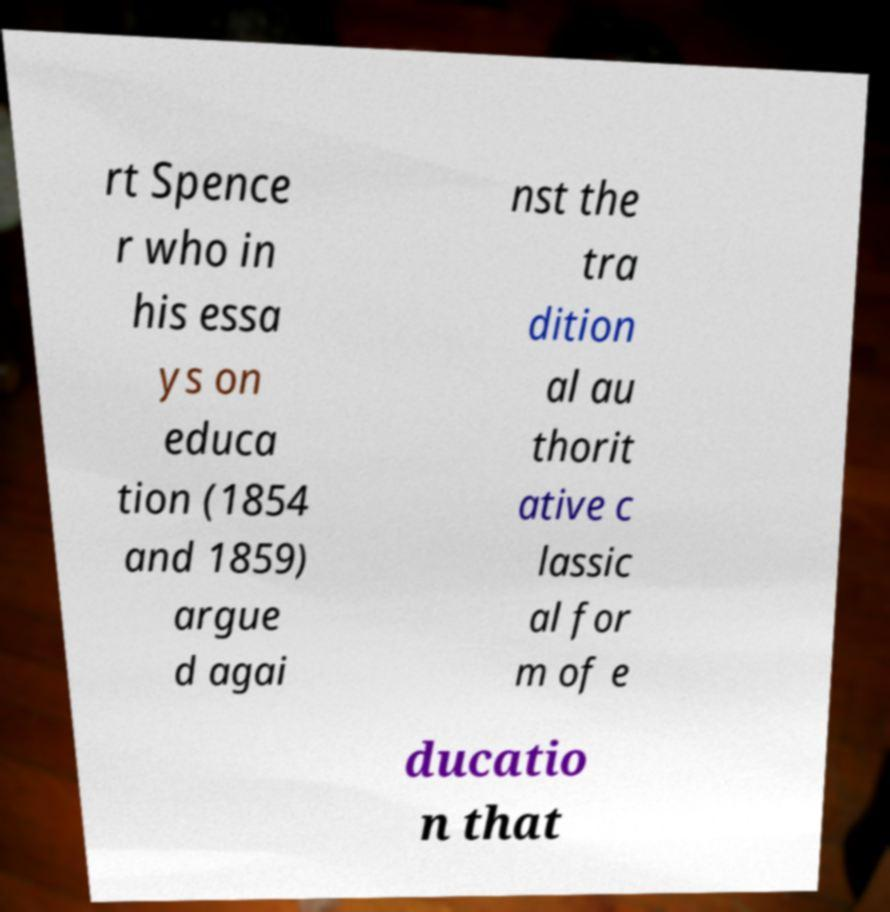Can you accurately transcribe the text from the provided image for me? rt Spence r who in his essa ys on educa tion (1854 and 1859) argue d agai nst the tra dition al au thorit ative c lassic al for m of e ducatio n that 